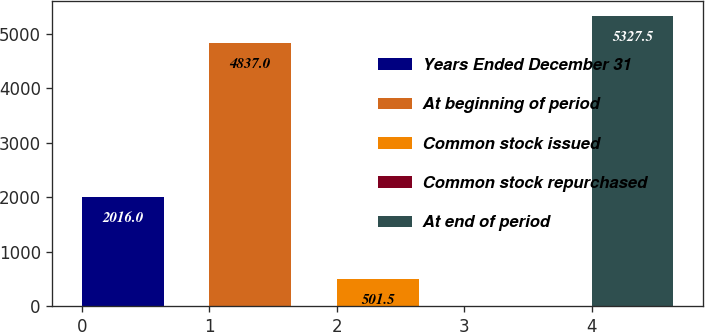<chart> <loc_0><loc_0><loc_500><loc_500><bar_chart><fcel>Years Ended December 31<fcel>At beginning of period<fcel>Common stock issued<fcel>Common stock repurchased<fcel>At end of period<nl><fcel>2016<fcel>4837<fcel>501.5<fcel>11<fcel>5327.5<nl></chart> 